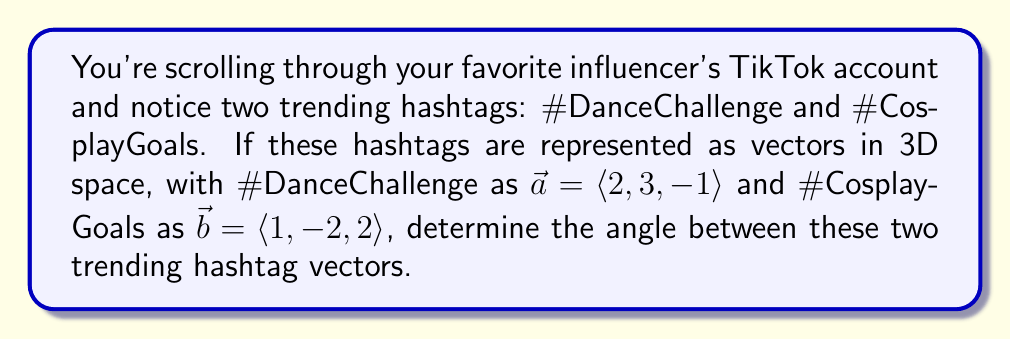Can you answer this question? To find the angle between two vectors in 3D space, we can use the dot product formula:

$$\cos \theta = \frac{\vec{a} \cdot \vec{b}}{|\vec{a}||\vec{b}|}$$

Step 1: Calculate the dot product $\vec{a} \cdot \vec{b}$
$$\vec{a} \cdot \vec{b} = (2)(1) + (3)(-2) + (-1)(2) = 2 - 6 - 2 = -6$$

Step 2: Calculate the magnitudes of $\vec{a}$ and $\vec{b}$
$$|\vec{a}| = \sqrt{2^2 + 3^2 + (-1)^2} = \sqrt{4 + 9 + 1} = \sqrt{14}$$
$$|\vec{b}| = \sqrt{1^2 + (-2)^2 + 2^2} = \sqrt{1 + 4 + 4} = 3$$

Step 3: Substitute the values into the formula
$$\cos \theta = \frac{-6}{\sqrt{14} \cdot 3}$$

Step 4: Simplify
$$\cos \theta = -\frac{2}{\sqrt{14}}$$

Step 5: Take the inverse cosine (arccos) of both sides
$$\theta = \arccos\left(-\frac{2}{\sqrt{14}}\right)$$

Step 6: Calculate the result (rounded to two decimal places)
$$\theta \approx 2.41 \text{ radians}$$

Convert to degrees:
$$\theta \approx 2.41 \cdot \frac{180^{\circ}}{\pi} \approx 138.11^{\circ}$$
Answer: $138.11^{\circ}$ 